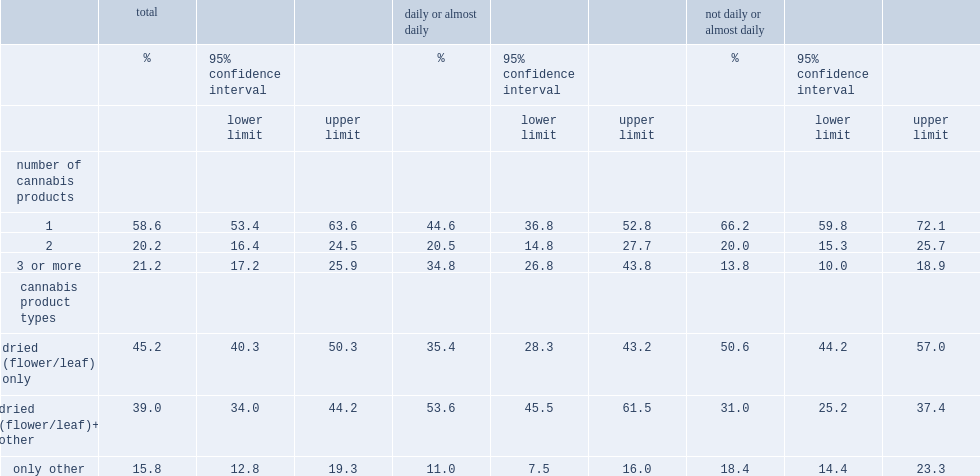What the rate of cannabis consumers reported using one product according to ncs q1 2019? 58.6. What the rate of cannabis consumers reported using two products according to ncs q1 2019? 20.2. What the rate of cannabis consumers reported using three or more products according to ncs q1 2019? 21.2. What the rate of dried(flower/leaf) cannabis used by consumers? 84.2. What the rate of dried (flower/leaf) was the only product used? 45.2. What the rate of dried (flower/leaf) was reported with at least one other product? 39.0. What the remainder reported using products other than dried (flower/leaf)? 15.8. How many times was the use of three or more products more often among dad users than those using less often? 2.521739. Which group users were more likely to use dried cannabis (flower/leaf) in addition to other products? Daily or almost daily. Which group users were less likely to use other (non-dried) cannabis products? Daily or almost daily. 